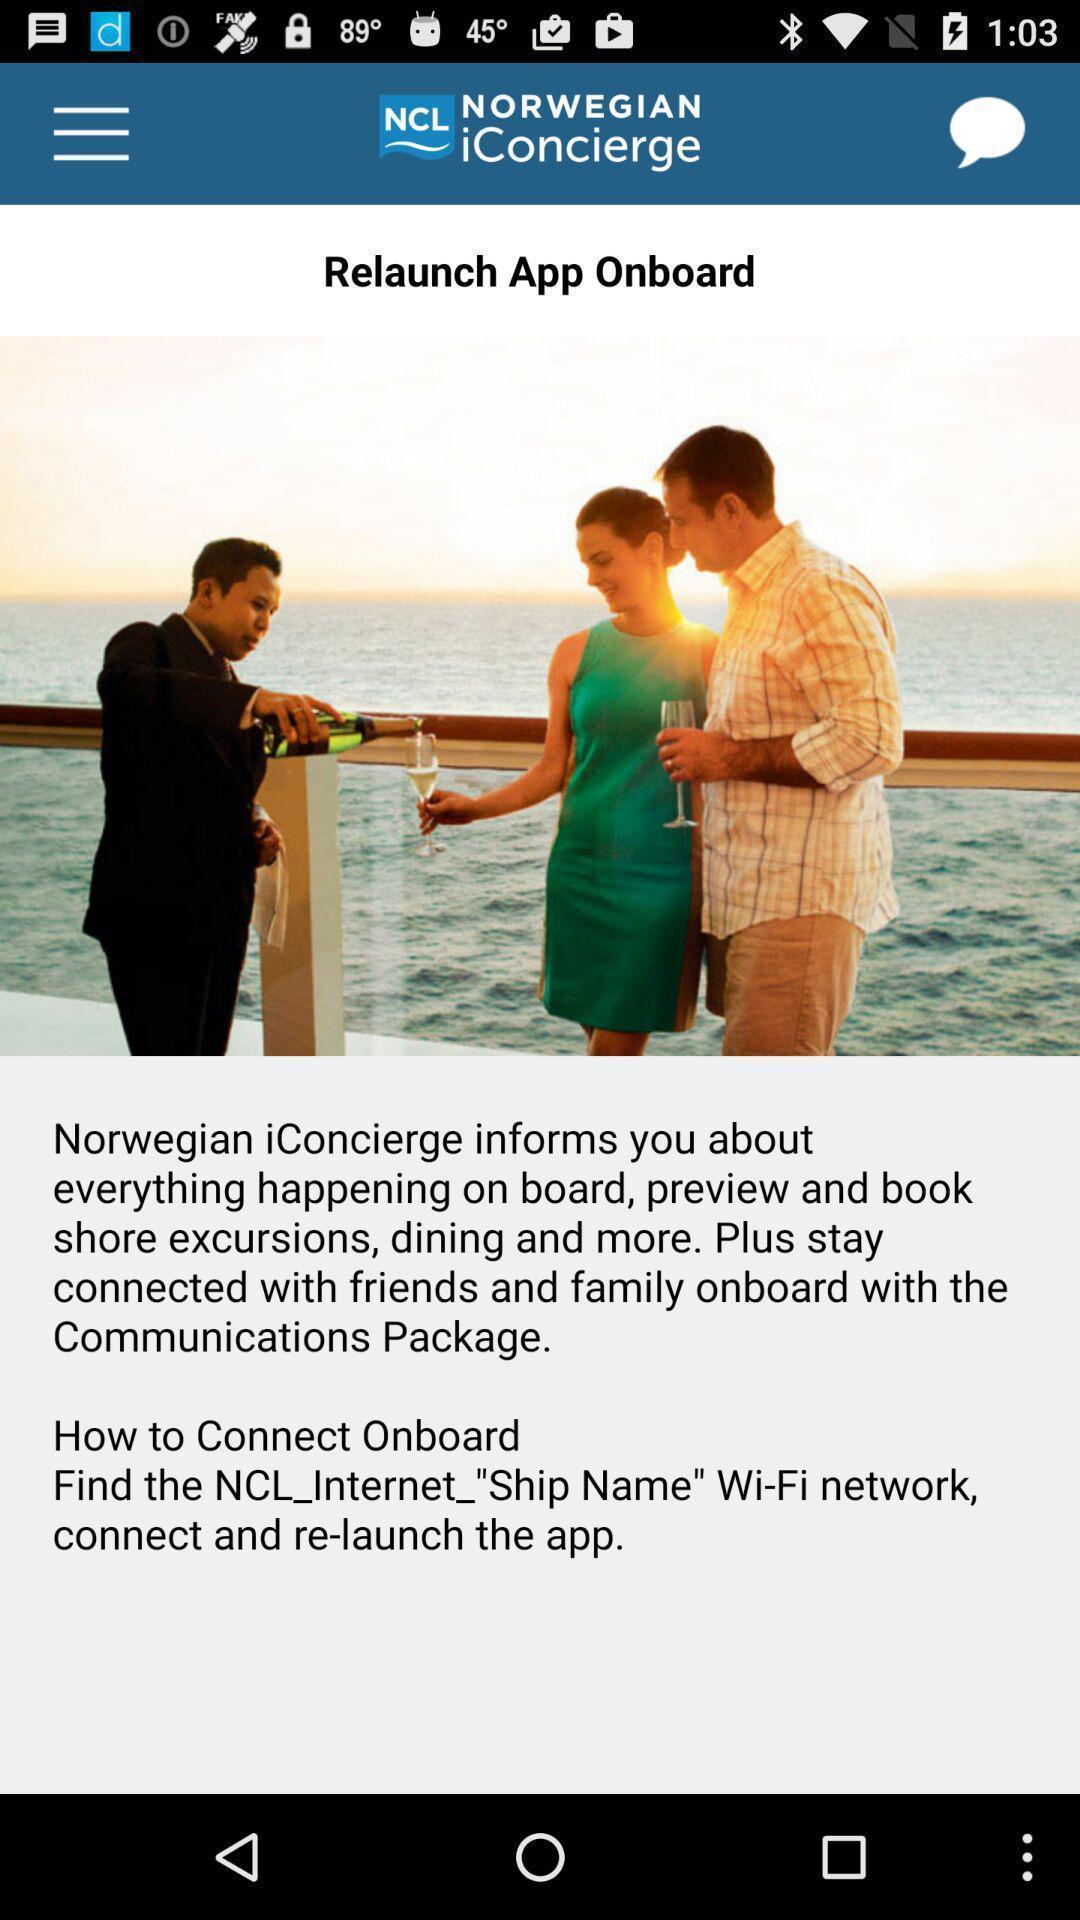Describe the content in this image. Screen shows relaunch details of a travel app. 